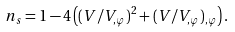<formula> <loc_0><loc_0><loc_500><loc_500>n _ { s } = 1 - 4 \left ( ( V / V _ { , \varphi } ) ^ { 2 } + ( V / V _ { , \varphi } ) _ { , \varphi } \right ) .</formula> 